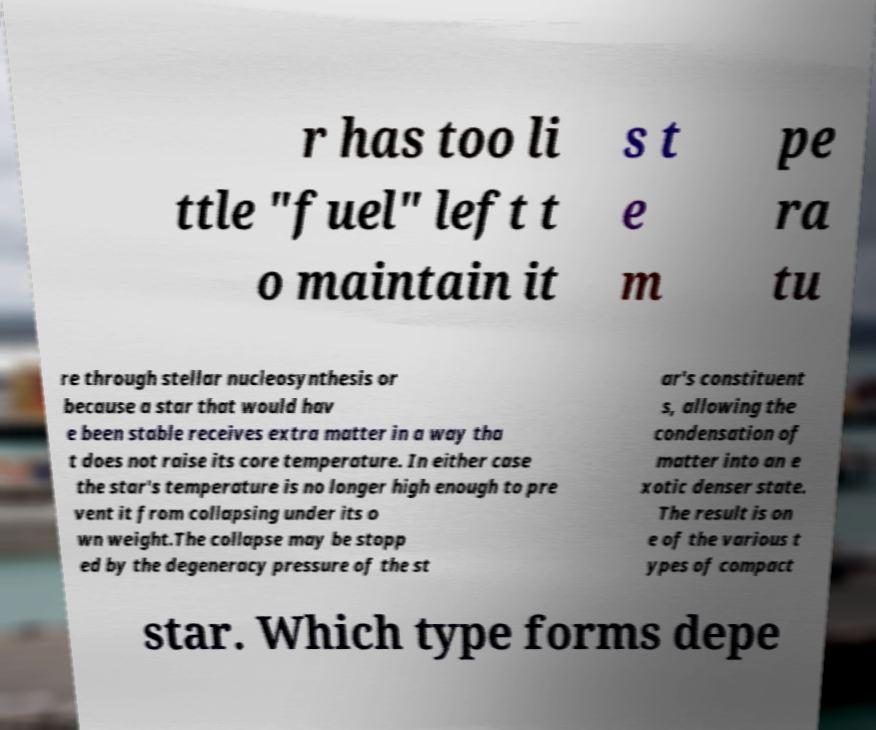Could you extract and type out the text from this image? r has too li ttle "fuel" left t o maintain it s t e m pe ra tu re through stellar nucleosynthesis or because a star that would hav e been stable receives extra matter in a way tha t does not raise its core temperature. In either case the star's temperature is no longer high enough to pre vent it from collapsing under its o wn weight.The collapse may be stopp ed by the degeneracy pressure of the st ar's constituent s, allowing the condensation of matter into an e xotic denser state. The result is on e of the various t ypes of compact star. Which type forms depe 